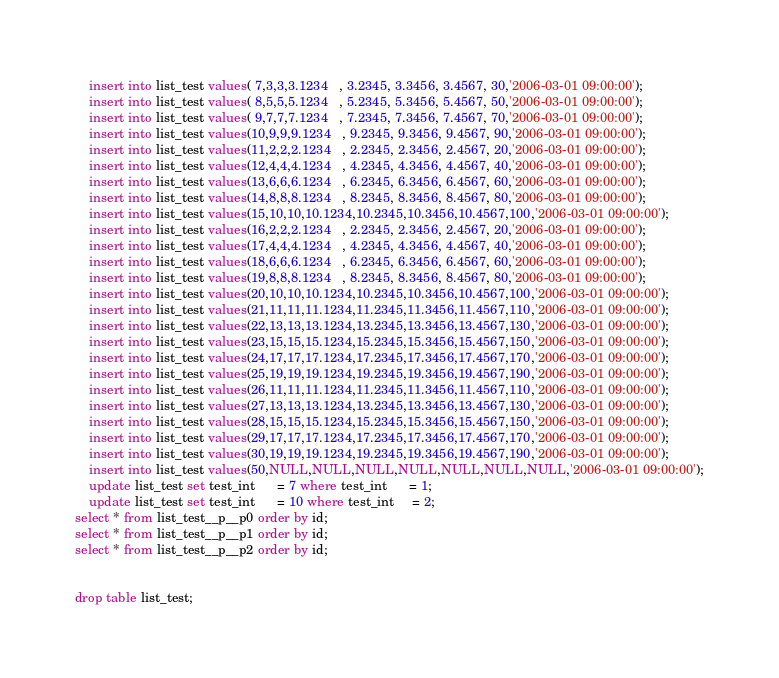<code> <loc_0><loc_0><loc_500><loc_500><_SQL_>	insert into list_test values( 7,3,3,3.1234   , 3.2345, 3.3456, 3.4567, 30,'2006-03-01 09:00:00');
	insert into list_test values( 8,5,5,5.1234   , 5.2345, 5.3456, 5.4567, 50,'2006-03-01 09:00:00');
	insert into list_test values( 9,7,7,7.1234   , 7.2345, 7.3456, 7.4567, 70,'2006-03-01 09:00:00');
	insert into list_test values(10,9,9,9.1234   , 9.2345, 9.3456, 9.4567, 90,'2006-03-01 09:00:00');
	insert into list_test values(11,2,2,2.1234   , 2.2345, 2.3456, 2.4567, 20,'2006-03-01 09:00:00');
	insert into list_test values(12,4,4,4.1234   , 4.2345, 4.3456, 4.4567, 40,'2006-03-01 09:00:00');
	insert into list_test values(13,6,6,6.1234   , 6.2345, 6.3456, 6.4567, 60,'2006-03-01 09:00:00');
	insert into list_test values(14,8,8,8.1234   , 8.2345, 8.3456, 8.4567, 80,'2006-03-01 09:00:00');
	insert into list_test values(15,10,10,10.1234,10.2345,10.3456,10.4567,100,'2006-03-01 09:00:00');
	insert into list_test values(16,2,2,2.1234   , 2.2345, 2.3456, 2.4567, 20,'2006-03-01 09:00:00');
	insert into list_test values(17,4,4,4.1234   , 4.2345, 4.3456, 4.4567, 40,'2006-03-01 09:00:00');
	insert into list_test values(18,6,6,6.1234   , 6.2345, 6.3456, 6.4567, 60,'2006-03-01 09:00:00');
	insert into list_test values(19,8,8,8.1234   , 8.2345, 8.3456, 8.4567, 80,'2006-03-01 09:00:00');
	insert into list_test values(20,10,10,10.1234,10.2345,10.3456,10.4567,100,'2006-03-01 09:00:00');
	insert into list_test values(21,11,11,11.1234,11.2345,11.3456,11.4567,110,'2006-03-01 09:00:00');
	insert into list_test values(22,13,13,13.1234,13.2345,13.3456,13.4567,130,'2006-03-01 09:00:00');
	insert into list_test values(23,15,15,15.1234,15.2345,15.3456,15.4567,150,'2006-03-01 09:00:00');
	insert into list_test values(24,17,17,17.1234,17.2345,17.3456,17.4567,170,'2006-03-01 09:00:00');
	insert into list_test values(25,19,19,19.1234,19.2345,19.3456,19.4567,190,'2006-03-01 09:00:00');
	insert into list_test values(26,11,11,11.1234,11.2345,11.3456,11.4567,110,'2006-03-01 09:00:00');
	insert into list_test values(27,13,13,13.1234,13.2345,13.3456,13.4567,130,'2006-03-01 09:00:00');
	insert into list_test values(28,15,15,15.1234,15.2345,15.3456,15.4567,150,'2006-03-01 09:00:00');
	insert into list_test values(29,17,17,17.1234,17.2345,17.3456,17.4567,170,'2006-03-01 09:00:00');
	insert into list_test values(30,19,19,19.1234,19.2345,19.3456,19.4567,190,'2006-03-01 09:00:00');
	insert into list_test values(50,NULL,NULL,NULL,NULL,NULL,NULL,NULL,'2006-03-01 09:00:00');
	update list_test set test_int      = 7 where test_int      = 1;
	update list_test set test_int      = 10 where test_int     = 2;
select * from list_test__p__p0 order by id;
select * from list_test__p__p1 order by id;
select * from list_test__p__p2 order by id;


drop table list_test;
</code> 